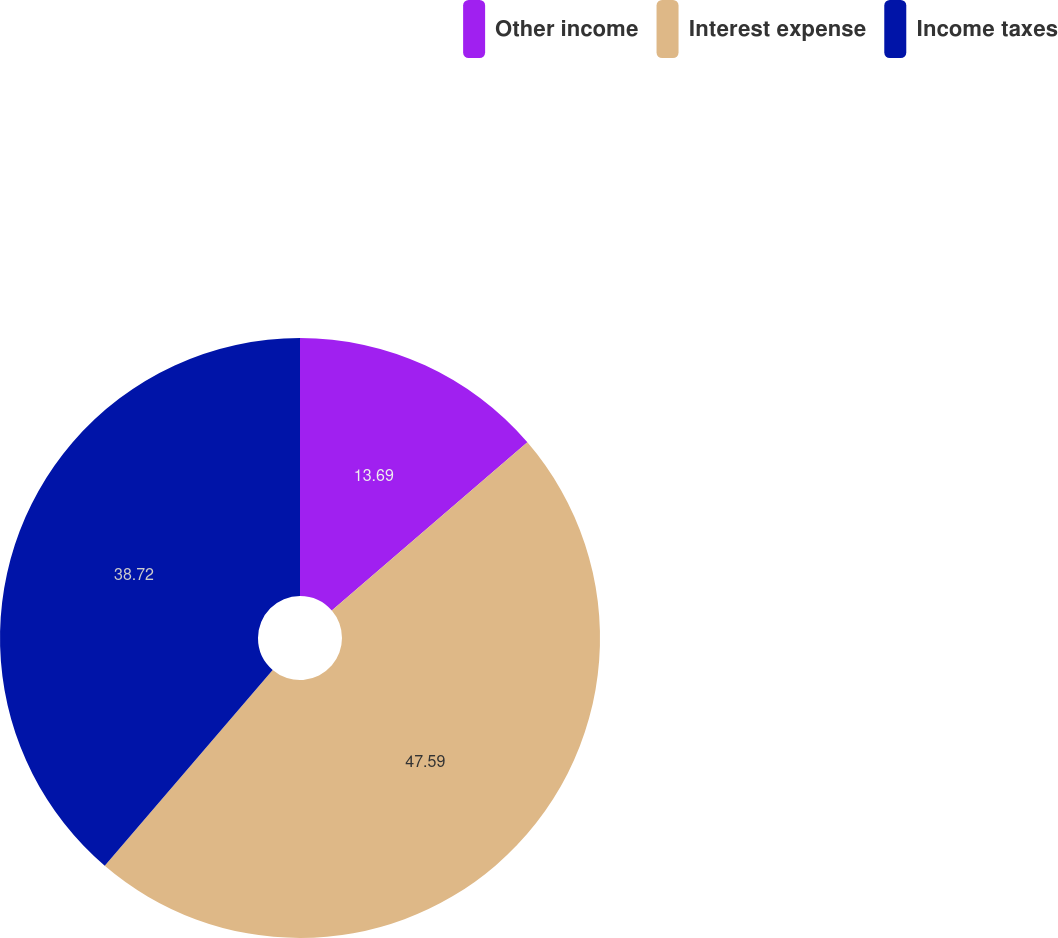Convert chart. <chart><loc_0><loc_0><loc_500><loc_500><pie_chart><fcel>Other income<fcel>Interest expense<fcel>Income taxes<nl><fcel>13.69%<fcel>47.59%<fcel>38.72%<nl></chart> 